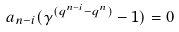<formula> <loc_0><loc_0><loc_500><loc_500>a _ { n - i } ( \gamma ^ { ( q ^ { n - i } - q ^ { n } ) } - 1 ) = 0</formula> 